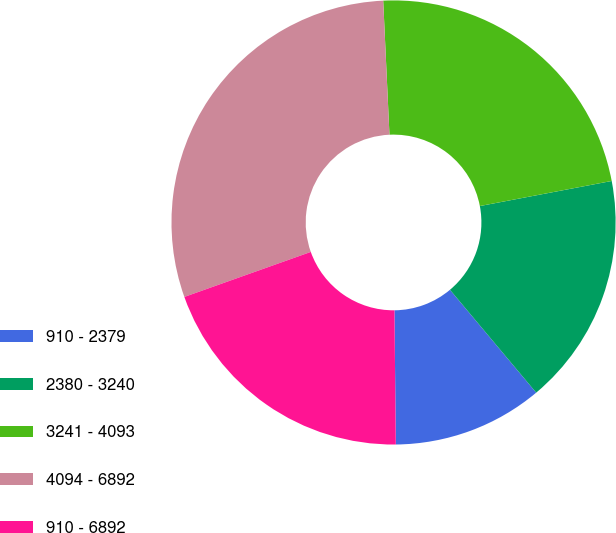Convert chart. <chart><loc_0><loc_0><loc_500><loc_500><pie_chart><fcel>910 - 2379<fcel>2380 - 3240<fcel>3241 - 4093<fcel>4094 - 6892<fcel>910 - 6892<nl><fcel>10.94%<fcel>16.89%<fcel>22.75%<fcel>29.7%<fcel>19.72%<nl></chart> 